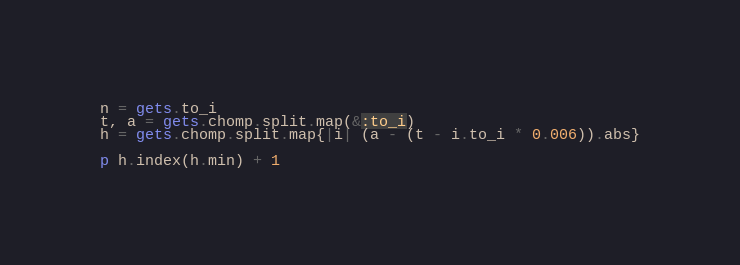<code> <loc_0><loc_0><loc_500><loc_500><_Ruby_>n = gets.to_i
t, a = gets.chomp.split.map(&:to_i)
h = gets.chomp.split.map{|i| (a - (t - i.to_i * 0.006)).abs}

p h.index(h.min) + 1</code> 